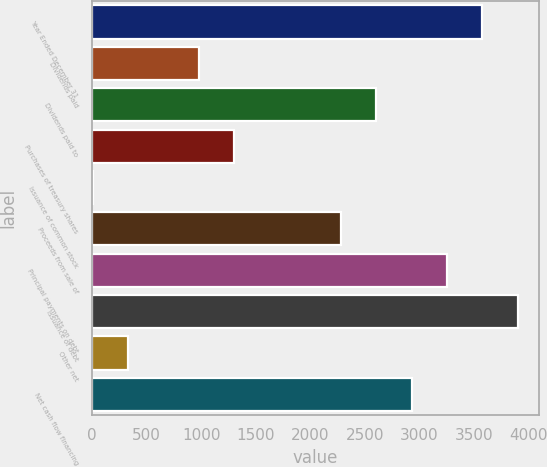Convert chart to OTSL. <chart><loc_0><loc_0><loc_500><loc_500><bar_chart><fcel>Year Ended December 31<fcel>Dividends paid<fcel>Dividends paid to<fcel>Purchases of treasury shares<fcel>Issuance of common stock<fcel>Proceeds from sale of<fcel>Principal payments on debt<fcel>Issuance of debt<fcel>Other net<fcel>Net cash flow financing<nl><fcel>3580<fcel>980<fcel>2605<fcel>1305<fcel>5<fcel>2280<fcel>3255<fcel>3905<fcel>330<fcel>2930<nl></chart> 